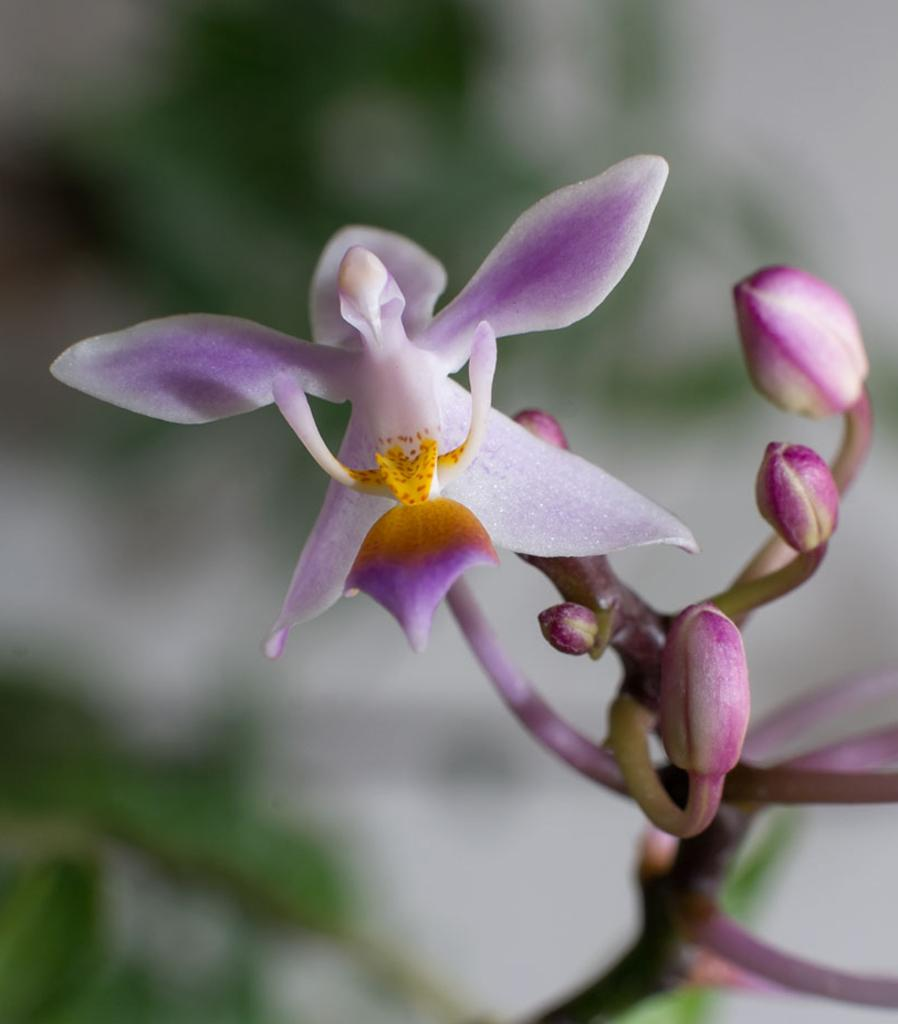What is the main subject of the image? The main subject of the image is a plant stem. What can be seen growing from the plant stem? There is a flower and buds visible in the image. How would you describe the background of the image? The background of the image is blurred. What type of fear is depicted in the image? There is no fear depicted in the image; it features a plant with a stem, flower, and buds. What type of learning is taking place in the image? There is no learning depicted in the image; it features a plant with a stem, flower, and buds. 